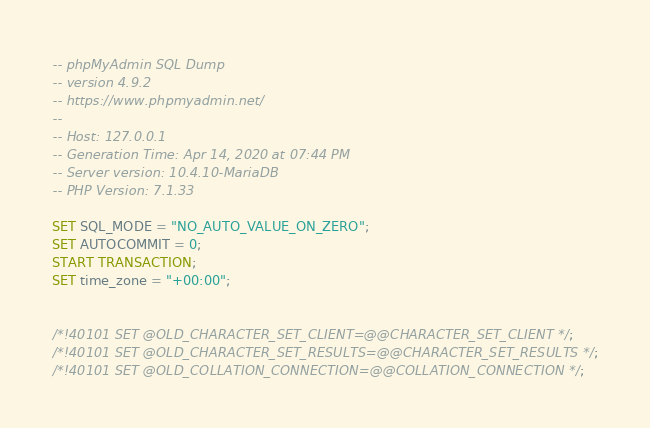Convert code to text. <code><loc_0><loc_0><loc_500><loc_500><_SQL_>-- phpMyAdmin SQL Dump
-- version 4.9.2
-- https://www.phpmyadmin.net/
--
-- Host: 127.0.0.1
-- Generation Time: Apr 14, 2020 at 07:44 PM
-- Server version: 10.4.10-MariaDB
-- PHP Version: 7.1.33

SET SQL_MODE = "NO_AUTO_VALUE_ON_ZERO";
SET AUTOCOMMIT = 0;
START TRANSACTION;
SET time_zone = "+00:00";


/*!40101 SET @OLD_CHARACTER_SET_CLIENT=@@CHARACTER_SET_CLIENT */;
/*!40101 SET @OLD_CHARACTER_SET_RESULTS=@@CHARACTER_SET_RESULTS */;
/*!40101 SET @OLD_COLLATION_CONNECTION=@@COLLATION_CONNECTION */;</code> 